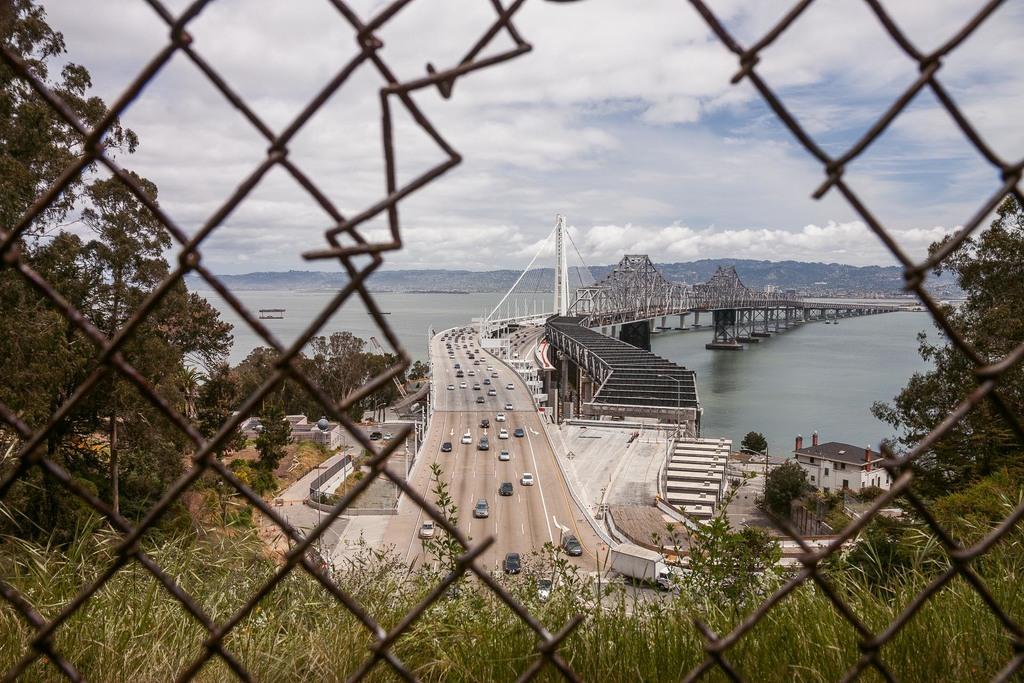Please provide a concise description of this image. In this image we can see fence, few plants, trees, vehicles on the road, bridge, water, mountains and the sky in the background. 